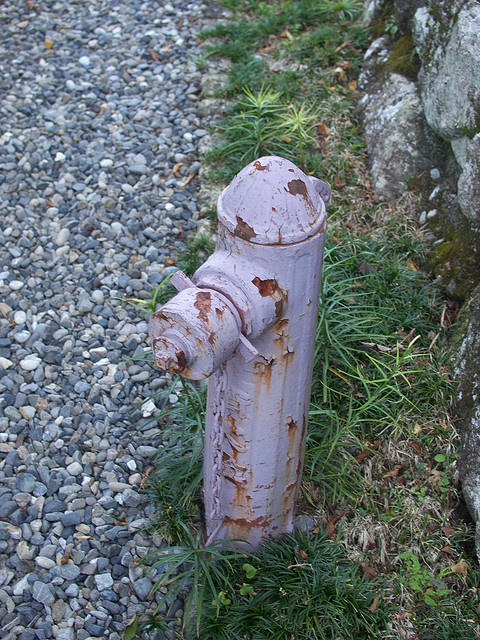Describe the objects in this image and their specific colors. I can see a fire hydrant in gray and darkgray tones in this image. 